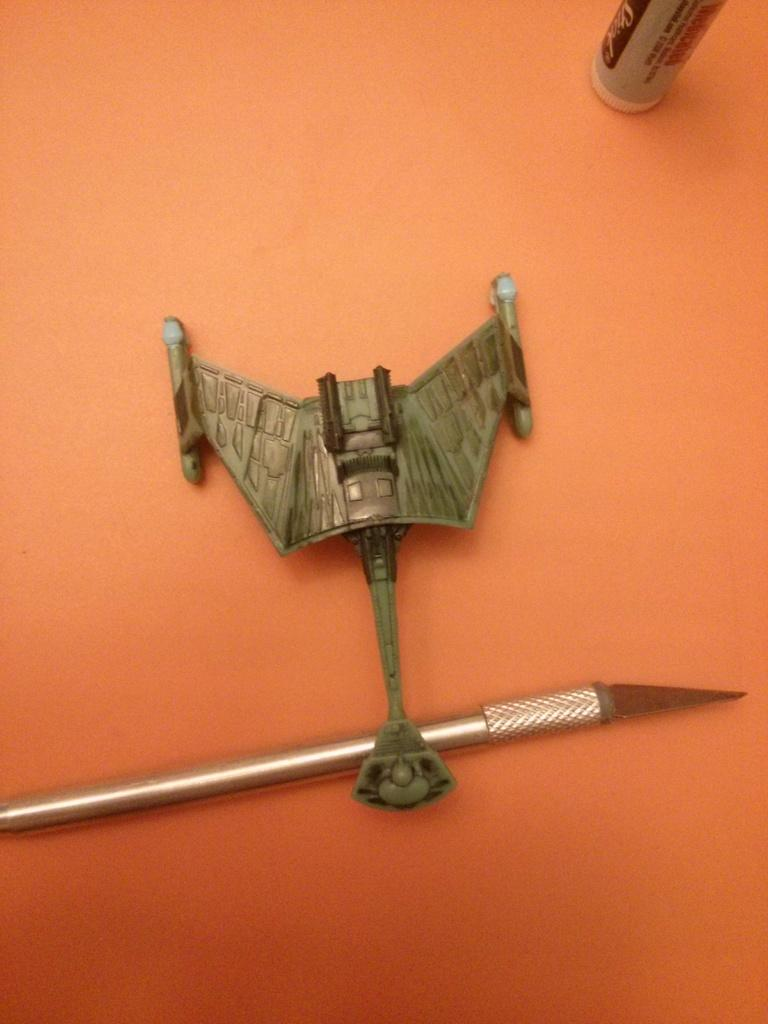What object in the image can be used for a specific purpose? There is a tool in the image that can be used for a specific purpose. What is located on the table in the image? There is a box on the table in the image. What type of land can be seen in the image? There is no land visible in the image; it only contains a tool and a box on a table. 